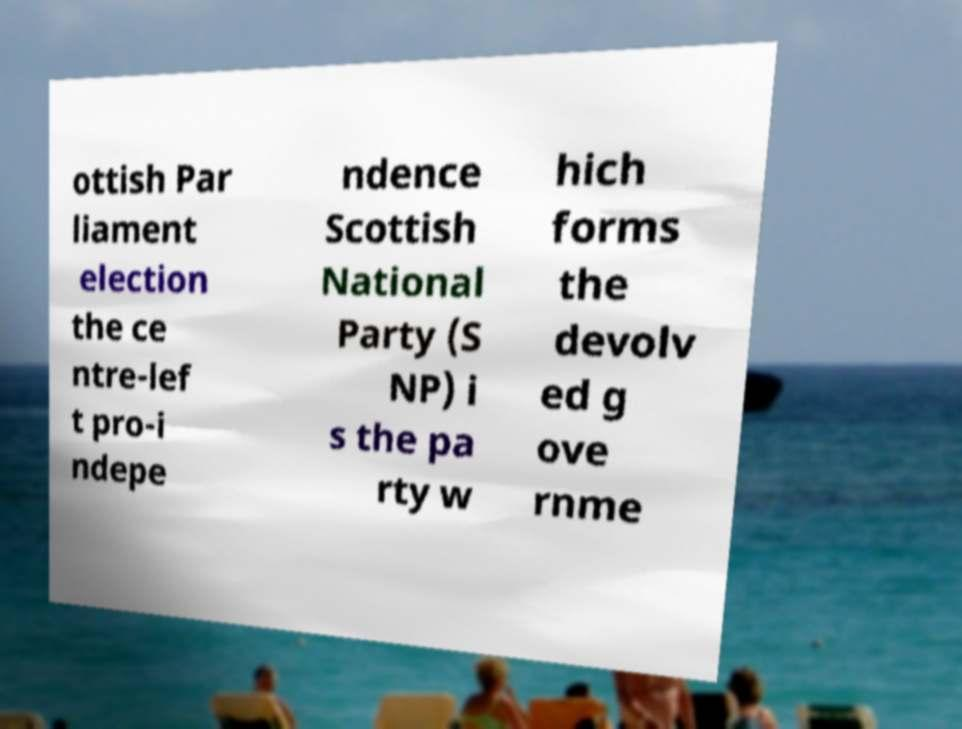Please read and relay the text visible in this image. What does it say? ottish Par liament election the ce ntre-lef t pro-i ndepe ndence Scottish National Party (S NP) i s the pa rty w hich forms the devolv ed g ove rnme 